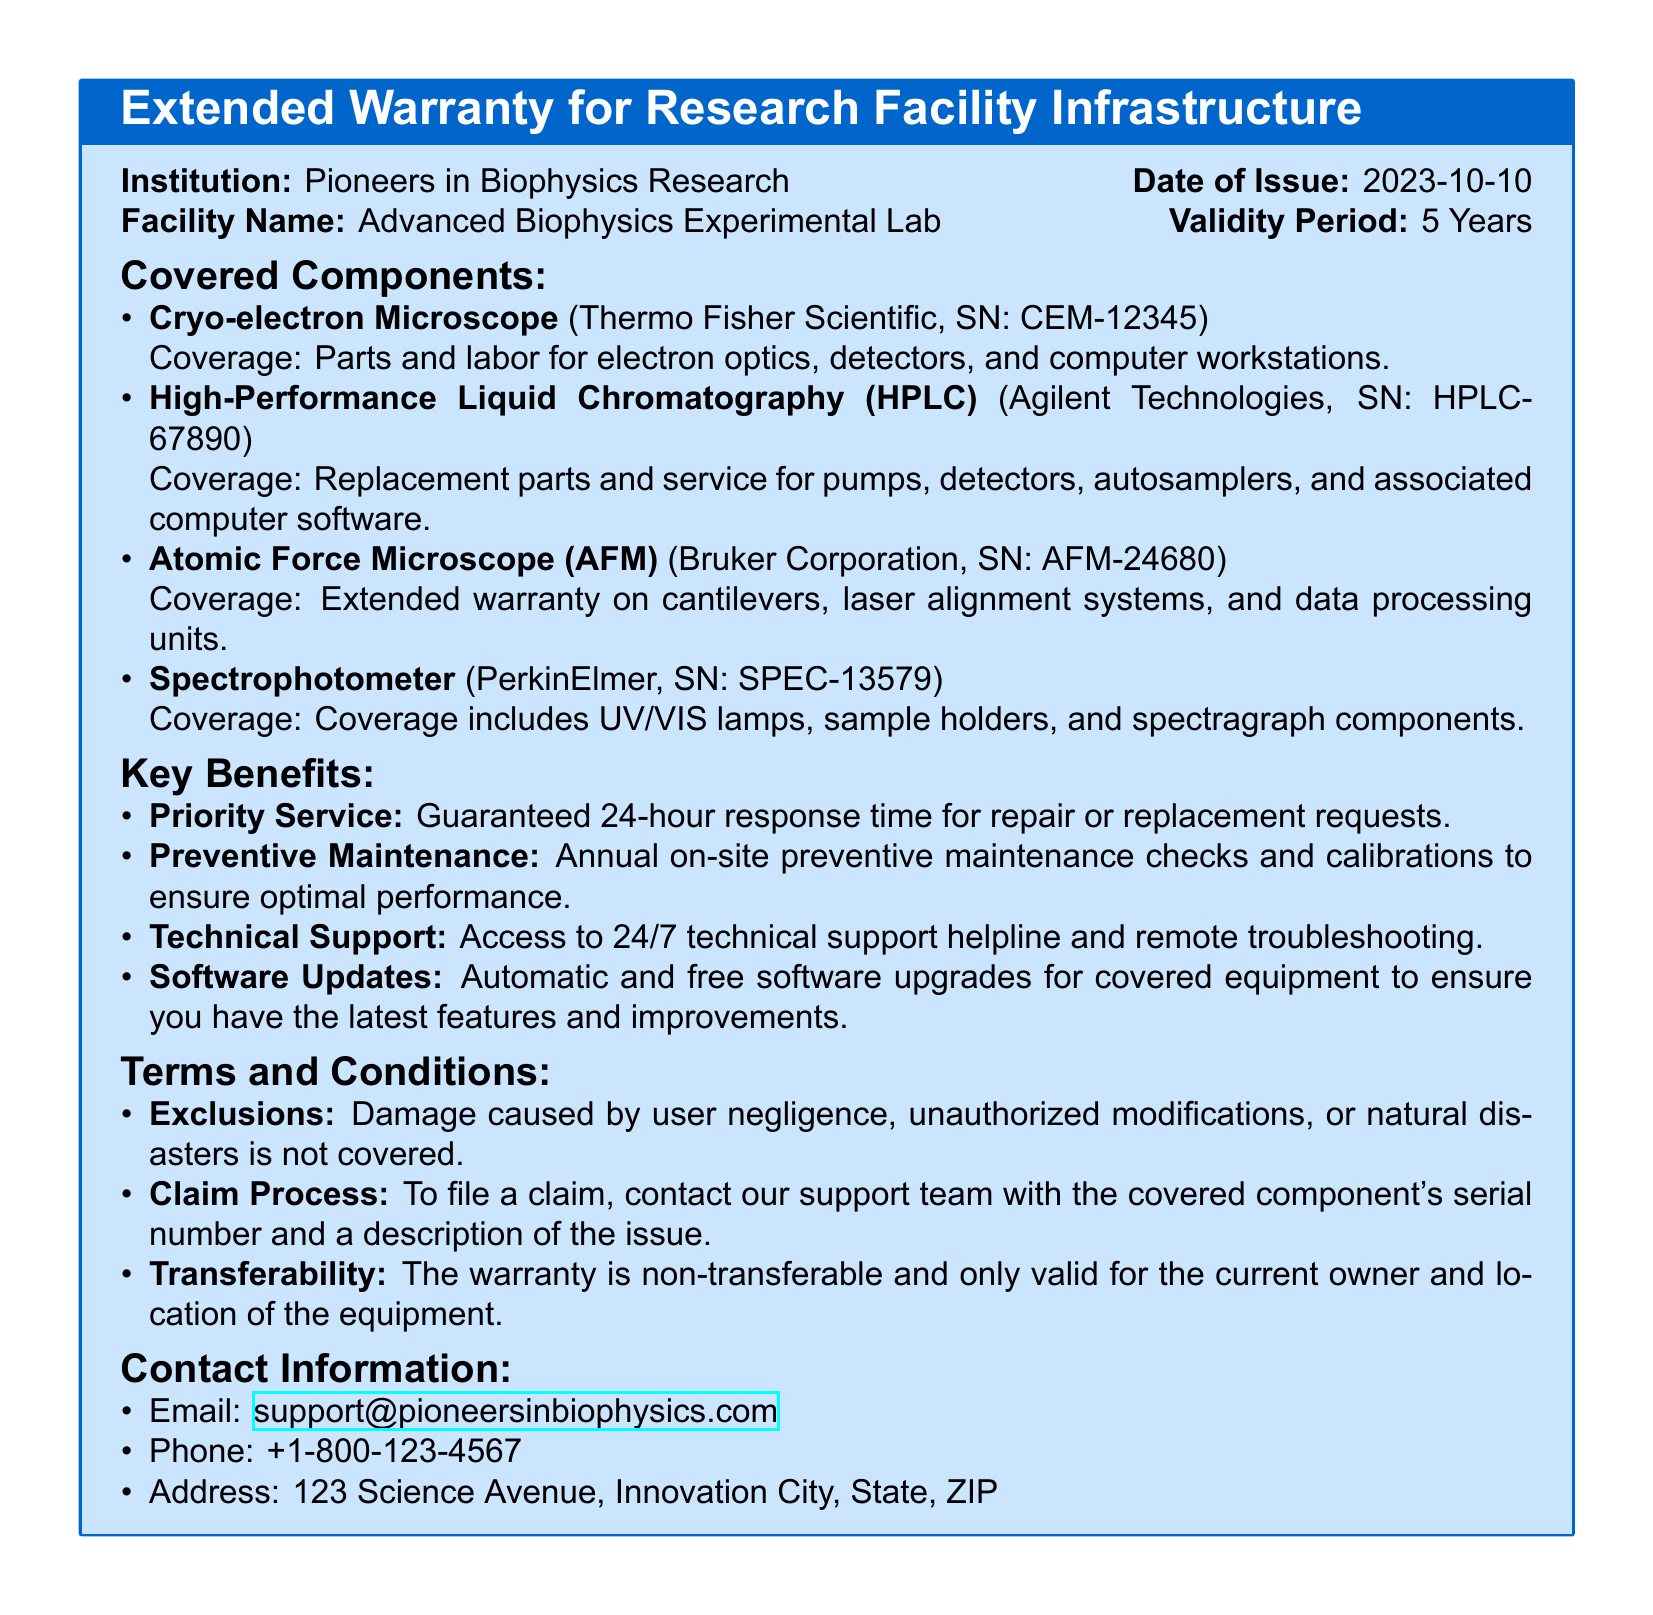What is the validity period of the warranty? The validity period is specified in the document as 5 years.
Answer: 5 Years Who is the institution providing the warranty? The document states the institution's name as "Pioneers in Biophysics Research."
Answer: Pioneers in Biophysics Research What component is covered under the warranty with serial number CEM-12345? The document specifies that the component is a "Cryo-electron Microscope."
Answer: Cryo-electron Microscope What is the guaranteed response time for repair requests? The document mentions a guarantee of a 24-hour response time for repair or replacement requests.
Answer: 24-hour What is excluded from the warranty coverage? The document indicates that damage caused by user negligence, unauthorized modifications, or natural disasters is not covered.
Answer: User negligence, unauthorized modifications, natural disasters How often are preventive maintenance checks conducted? The document states that annual on-site preventive maintenance checks are performed.
Answer: Annual What type of support is available 24/7? The document specifies "technical support" as being available around the clock.
Answer: Technical support Is the warranty transferable? The document explicitly states that the warranty is non-transferable.
Answer: Non-transferable 